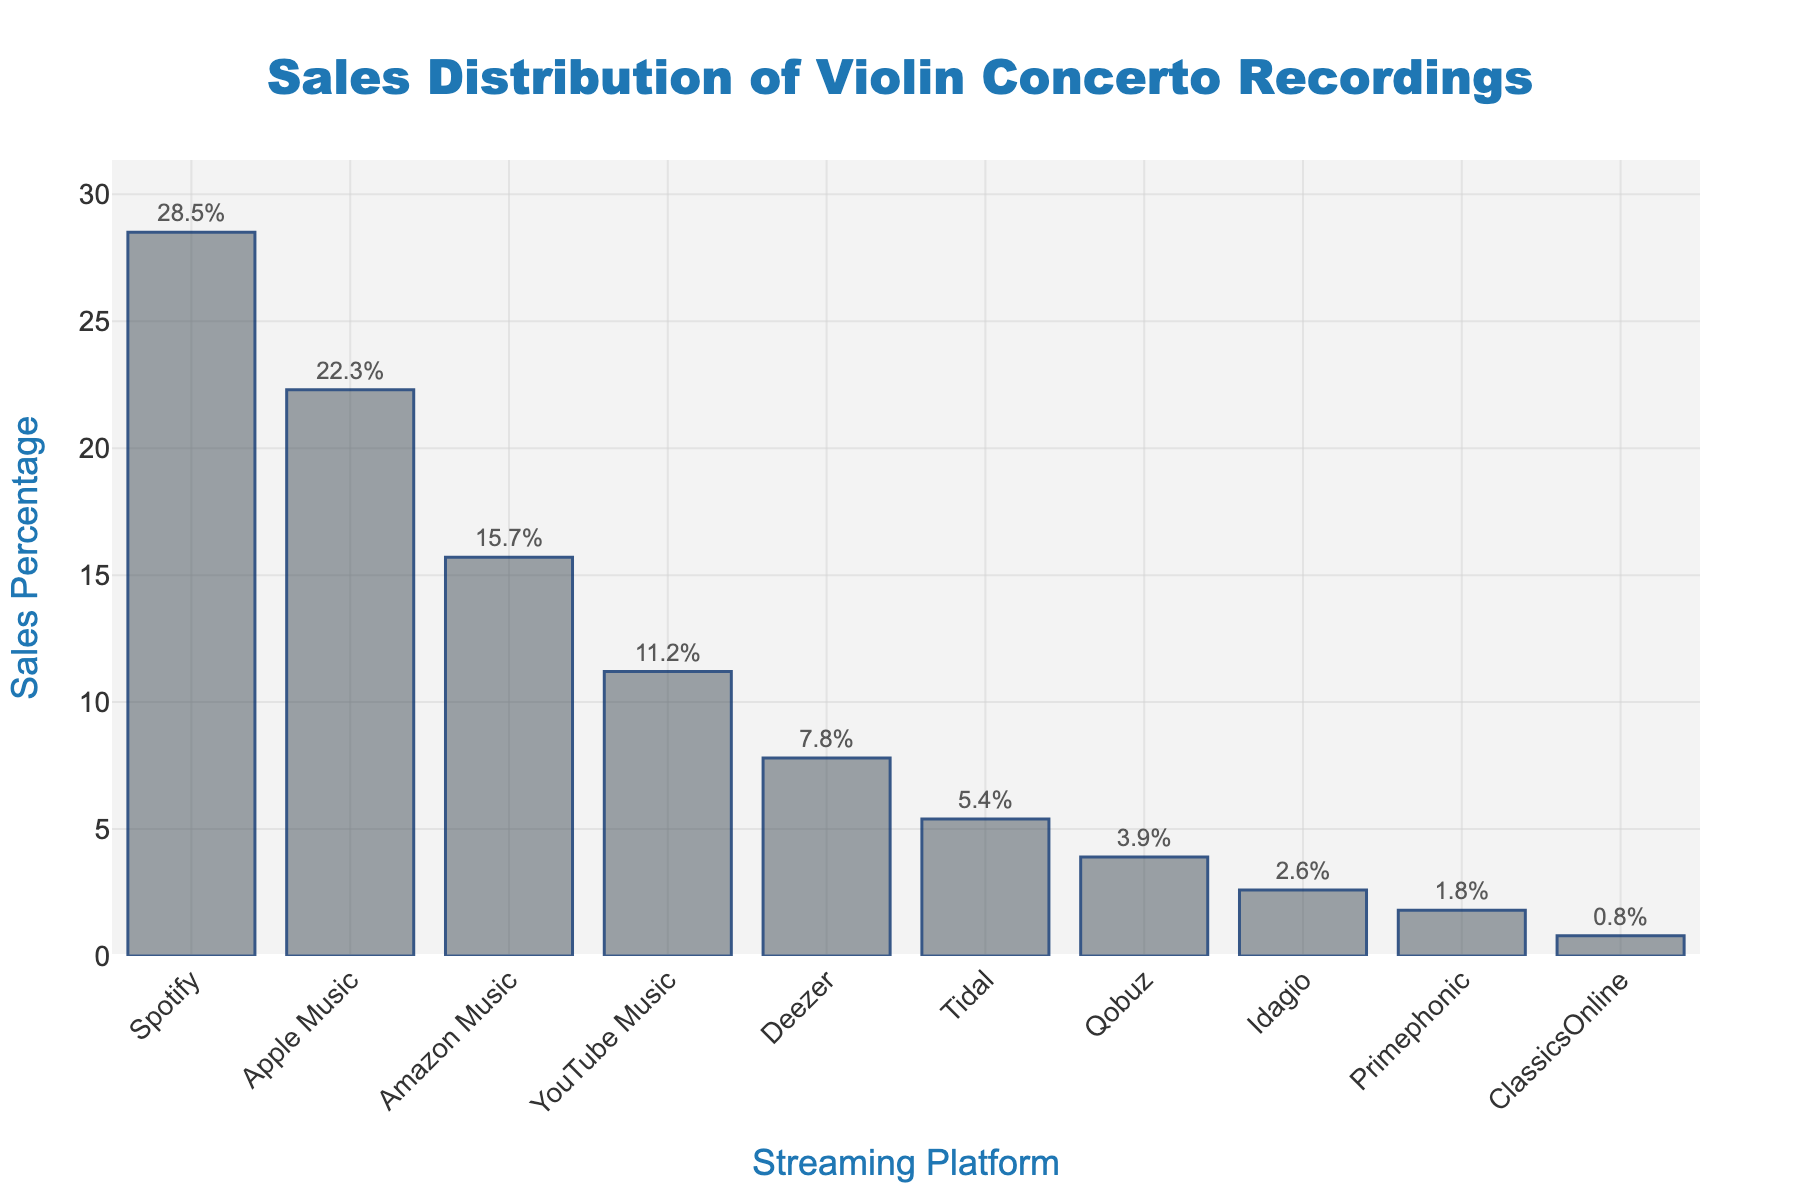Which platform has the highest sales percentage? The bar chart shows that Spotify has the highest bar, indicating it has the highest sales percentage compared to other platforms.
Answer: Spotify How much greater is Spotify's sales percentage compared to Apple Music's? To find the difference, subtract Apple Music's sales percentage (22.3%) from Spotify's sales percentage (28.5%): 28.5 - 22.3 = 6.2.
Answer: 6.2% What is the combined sales percentage of Amazon Music, Deezer, and Idagio? Add the sales percentages of Amazon Music (15.7%), Deezer (7.8%), and Idagio (2.6%): 15.7 + 7.8 + 2.6 = 26.1.
Answer: 26.1% Which platform has a sales percentage closest to 5%? By observing the lengths of the bars, Tidal, with a sales percentage of 5.4%, is closest to 5%.
Answer: Tidal How much smaller is Primephonic's sales percentage compared to YouTube Music's? Subtract Primephonic's sales percentage (1.8%) from YouTube Music's (11.2%): 11.2 - 1.8 = 9.4.
Answer: 9.4% Which platforms have sales percentages less than 4%? Platforms with bars reaching less than the height representing 4% are Qobuz (3.9%), Idagio (2.6%), Primephonic (1.8%), and ClassicsOnline (0.8%).
Answer: Qobuz, Idagio, Primephonic, ClassicsOnline Are there more platforms with sales percentages above or below 10%? Count the platforms with sales percentages above 10% (Spotify, Apple Music, Amazon Music, YouTube Music) and below 10% (Deezer, Tidal, Qobuz, Idagio, Primephonic, ClassicsOnline). Above 10% = 4 platforms; below 10% = 6 platforms.
Answer: Below 10% What is the median sales percentage value among all platforms? Sort the percentages and find the median of the 10 values: (0.8, 1.8, 2.6, 3.9, 5.4, 7.8, 11.2, 15.7, 22.3, 28.5). The median is the average of the 5th and 6th values: (5.4 + 7.8) / 2 = 6.6.
Answer: 6.6% 